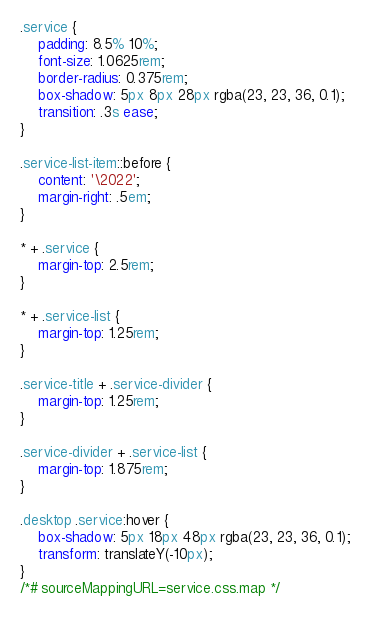<code> <loc_0><loc_0><loc_500><loc_500><_CSS_>.service {	padding: 8.5% 10%;	font-size: 1.0625rem;	border-radius: 0.375rem;	box-shadow: 5px 8px 28px rgba(23, 23, 36, 0.1);	transition: .3s ease;}.service-list-item::before {	content: '\2022';	margin-right: .5em;}* + .service {	margin-top: 2.5rem;}* + .service-list {	margin-top: 1.25rem;}.service-title + .service-divider {	margin-top: 1.25rem;}.service-divider + .service-list {	margin-top: 1.875rem;}.desktop .service:hover {	box-shadow: 5px 18px 48px rgba(23, 23, 36, 0.1);	transform: translateY(-10px);}
/*# sourceMappingURL=service.css.map */
</code> 